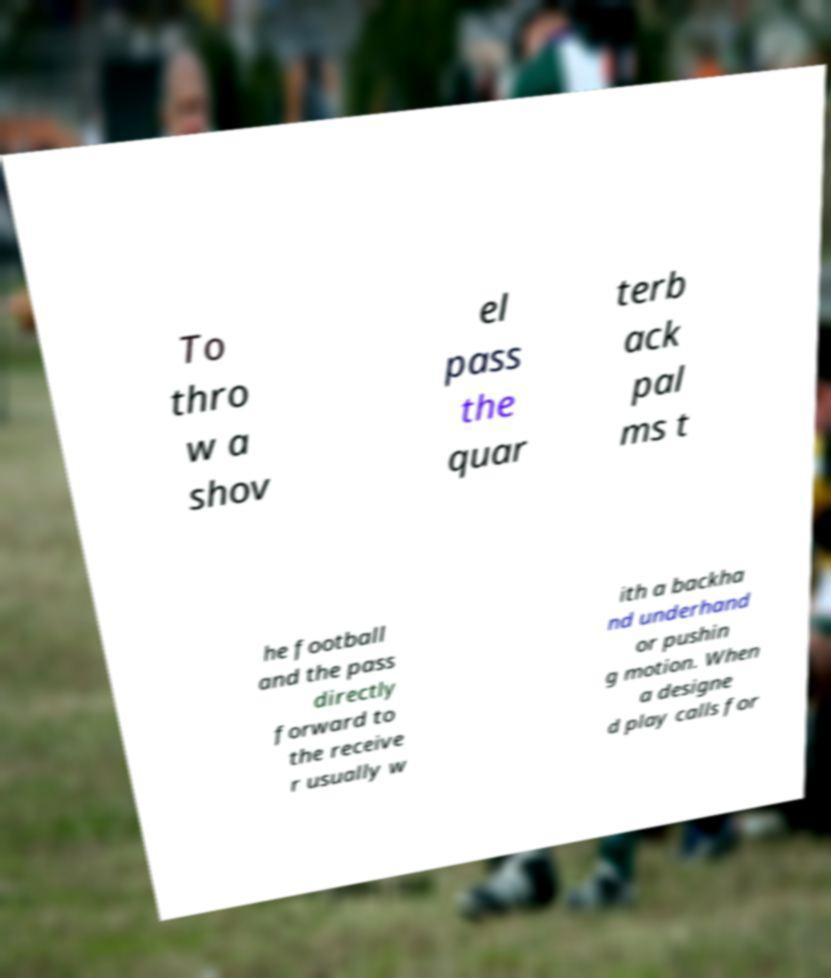Can you read and provide the text displayed in the image?This photo seems to have some interesting text. Can you extract and type it out for me? To thro w a shov el pass the quar terb ack pal ms t he football and the pass directly forward to the receive r usually w ith a backha nd underhand or pushin g motion. When a designe d play calls for 